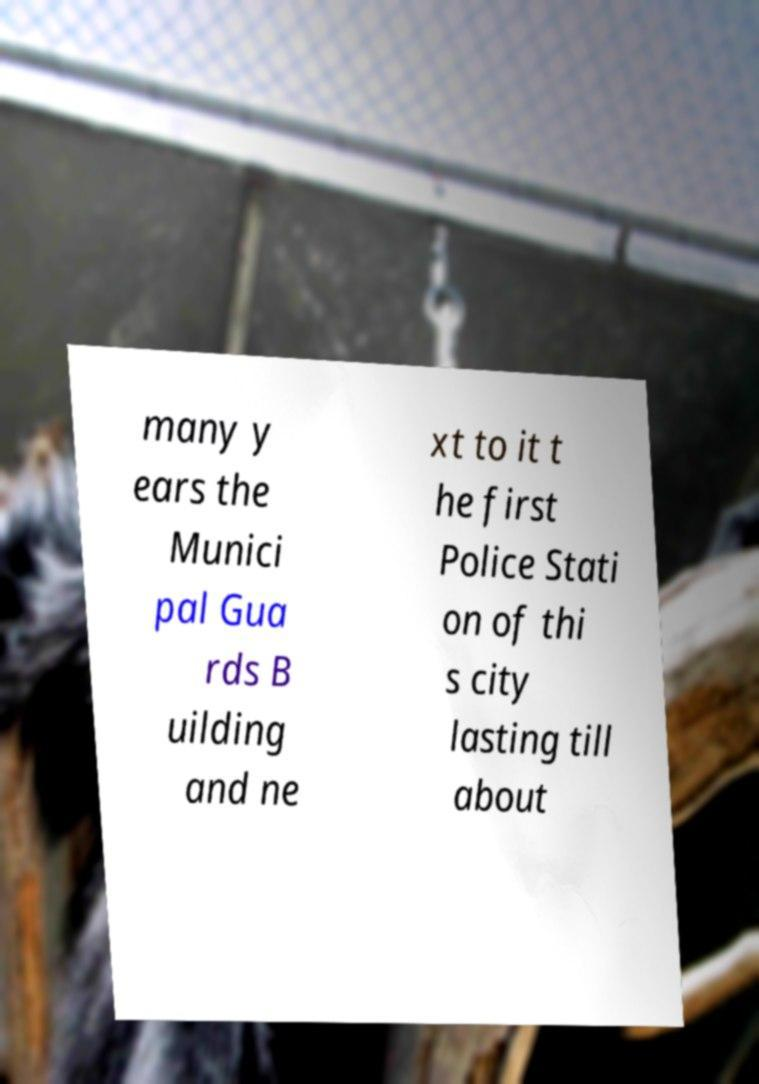For documentation purposes, I need the text within this image transcribed. Could you provide that? many y ears the Munici pal Gua rds B uilding and ne xt to it t he first Police Stati on of thi s city lasting till about 